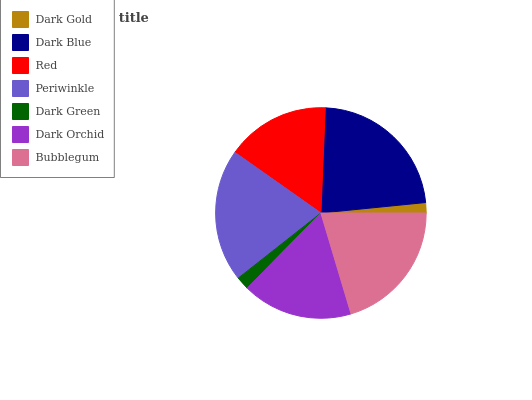Is Dark Gold the minimum?
Answer yes or no. Yes. Is Dark Blue the maximum?
Answer yes or no. Yes. Is Red the minimum?
Answer yes or no. No. Is Red the maximum?
Answer yes or no. No. Is Dark Blue greater than Red?
Answer yes or no. Yes. Is Red less than Dark Blue?
Answer yes or no. Yes. Is Red greater than Dark Blue?
Answer yes or no. No. Is Dark Blue less than Red?
Answer yes or no. No. Is Dark Orchid the high median?
Answer yes or no. Yes. Is Dark Orchid the low median?
Answer yes or no. Yes. Is Red the high median?
Answer yes or no. No. Is Dark Green the low median?
Answer yes or no. No. 